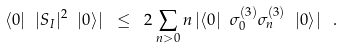<formula> <loc_0><loc_0><loc_500><loc_500>\langle 0 | \ | S _ { I } | ^ { 2 } \ | 0 \rangle | \ \leq \ 2 \sum _ { n > 0 } n \, | \langle 0 | \ \sigma ^ { ( 3 ) } _ { 0 } \sigma ^ { ( 3 ) } _ { n } \ | 0 \rangle | \ \, .</formula> 